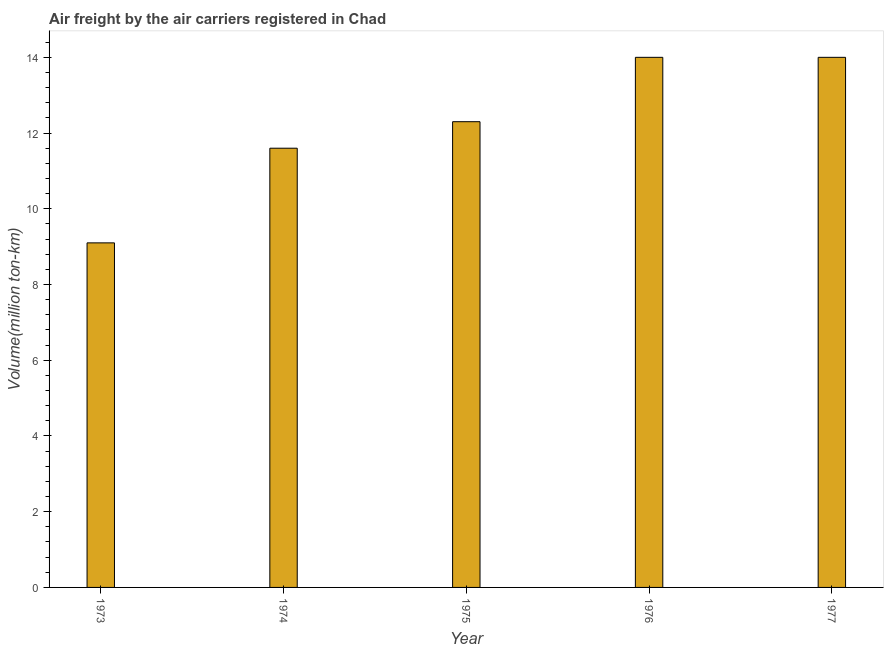Does the graph contain grids?
Make the answer very short. No. What is the title of the graph?
Ensure brevity in your answer.  Air freight by the air carriers registered in Chad. What is the label or title of the Y-axis?
Your answer should be very brief. Volume(million ton-km). What is the air freight in 1975?
Provide a succinct answer. 12.3. Across all years, what is the minimum air freight?
Keep it short and to the point. 9.1. In which year was the air freight maximum?
Ensure brevity in your answer.  1976. In which year was the air freight minimum?
Your answer should be compact. 1973. What is the sum of the air freight?
Keep it short and to the point. 61. What is the average air freight per year?
Provide a succinct answer. 12.2. What is the median air freight?
Offer a terse response. 12.3. In how many years, is the air freight greater than 3.2 million ton-km?
Your answer should be very brief. 5. Do a majority of the years between 1977 and 1976 (inclusive) have air freight greater than 8 million ton-km?
Give a very brief answer. No. What is the ratio of the air freight in 1975 to that in 1977?
Make the answer very short. 0.88. Is the air freight in 1976 less than that in 1977?
Offer a terse response. No. What is the difference between the highest and the second highest air freight?
Offer a very short reply. 0. What is the difference between the highest and the lowest air freight?
Ensure brevity in your answer.  4.9. In how many years, is the air freight greater than the average air freight taken over all years?
Ensure brevity in your answer.  3. Are all the bars in the graph horizontal?
Offer a very short reply. No. How many years are there in the graph?
Make the answer very short. 5. Are the values on the major ticks of Y-axis written in scientific E-notation?
Keep it short and to the point. No. What is the Volume(million ton-km) of 1973?
Offer a very short reply. 9.1. What is the Volume(million ton-km) of 1974?
Your response must be concise. 11.6. What is the Volume(million ton-km) of 1975?
Ensure brevity in your answer.  12.3. What is the Volume(million ton-km) in 1976?
Provide a short and direct response. 14. What is the difference between the Volume(million ton-km) in 1973 and 1975?
Keep it short and to the point. -3.2. What is the difference between the Volume(million ton-km) in 1973 and 1976?
Provide a succinct answer. -4.9. What is the difference between the Volume(million ton-km) in 1974 and 1976?
Offer a very short reply. -2.4. What is the difference between the Volume(million ton-km) in 1975 and 1977?
Give a very brief answer. -1.7. What is the difference between the Volume(million ton-km) in 1976 and 1977?
Ensure brevity in your answer.  0. What is the ratio of the Volume(million ton-km) in 1973 to that in 1974?
Provide a short and direct response. 0.78. What is the ratio of the Volume(million ton-km) in 1973 to that in 1975?
Offer a very short reply. 0.74. What is the ratio of the Volume(million ton-km) in 1973 to that in 1976?
Provide a short and direct response. 0.65. What is the ratio of the Volume(million ton-km) in 1973 to that in 1977?
Keep it short and to the point. 0.65. What is the ratio of the Volume(million ton-km) in 1974 to that in 1975?
Ensure brevity in your answer.  0.94. What is the ratio of the Volume(million ton-km) in 1974 to that in 1976?
Make the answer very short. 0.83. What is the ratio of the Volume(million ton-km) in 1974 to that in 1977?
Your response must be concise. 0.83. What is the ratio of the Volume(million ton-km) in 1975 to that in 1976?
Give a very brief answer. 0.88. What is the ratio of the Volume(million ton-km) in 1975 to that in 1977?
Your answer should be very brief. 0.88. 